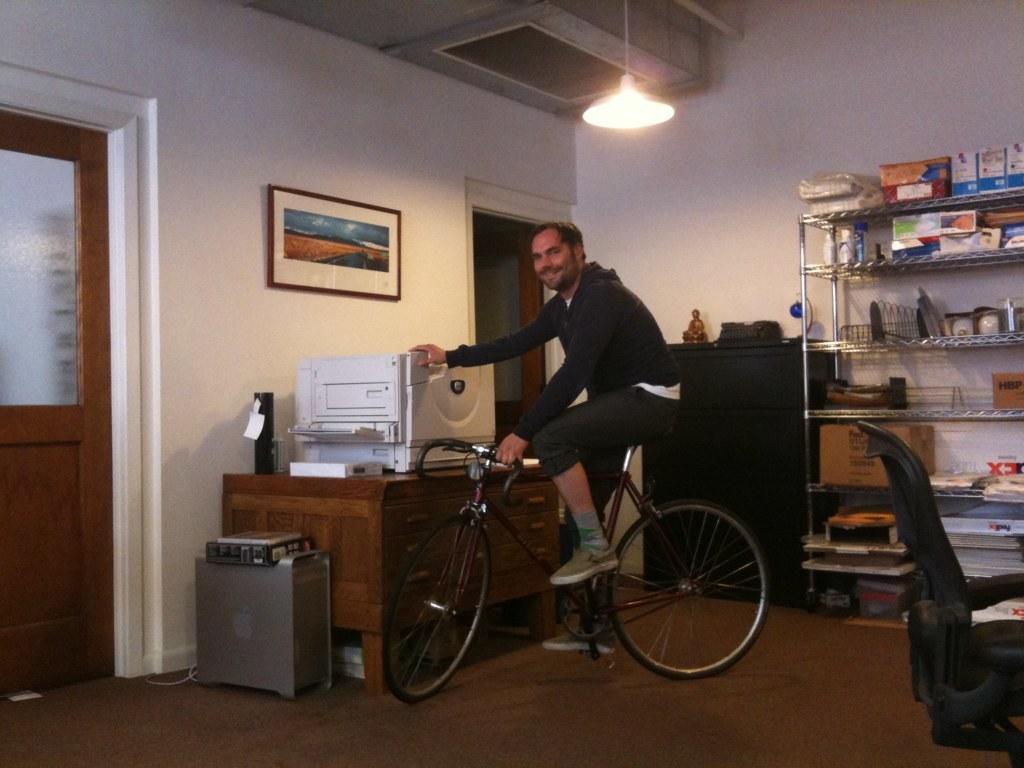Describe this image in one or two sentences. There is a room. He is sitting on a bicycle. He's holding a scanner. We can see in background photo frame ,window,cupboard,table,light. 